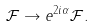Convert formula to latex. <formula><loc_0><loc_0><loc_500><loc_500>\mathcal { F } \rightarrow e ^ { 2 i \alpha } \mathcal { F } .</formula> 